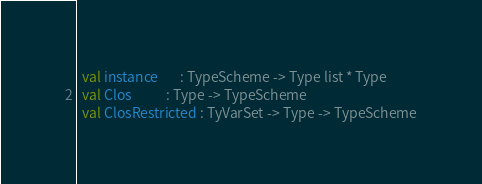Convert code to text. <code><loc_0><loc_0><loc_500><loc_500><_SML_>  val instance       : TypeScheme -> Type list * Type
  val Clos           : Type -> TypeScheme
  val ClosRestricted : TyVarSet -> Type -> TypeScheme</code> 